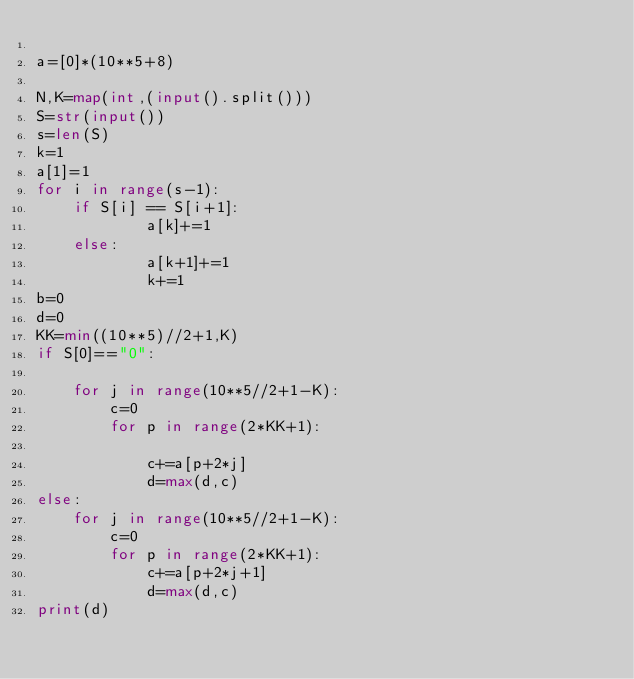<code> <loc_0><loc_0><loc_500><loc_500><_Python_>
a=[0]*(10**5+8)

N,K=map(int,(input().split()))
S=str(input())
s=len(S)
k=1
a[1]=1
for i in range(s-1):
    if S[i] == S[i+1]:
            a[k]+=1
    else:
            a[k+1]+=1
            k+=1
b=0
d=0
KK=min((10**5)//2+1,K)
if S[0]=="0":

    for j in range(10**5//2+1-K):
        c=0
        for p in range(2*KK+1):

            c+=a[p+2*j]
            d=max(d,c)
else:
    for j in range(10**5//2+1-K):
        c=0
        for p in range(2*KK+1):
            c+=a[p+2*j+1]
            d=max(d,c)
print(d)</code> 